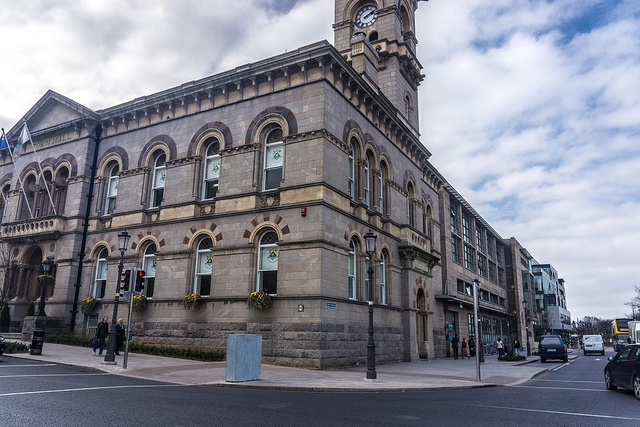Describe the objects in this image and their specific colors. I can see car in white, black, gray, and blue tones, car in white, black, navy, and gray tones, clock in white, gray, black, and darkgray tones, truck in white, darkgray, black, and lightgray tones, and people in white, black, gray, and navy tones in this image. 